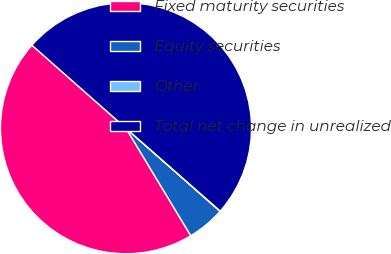Convert chart. <chart><loc_0><loc_0><loc_500><loc_500><pie_chart><fcel>Fixed maturity securities<fcel>Equity securities<fcel>Other<fcel>Total net change in unrealized<nl><fcel>45.15%<fcel>4.85%<fcel>0.04%<fcel>49.96%<nl></chart> 